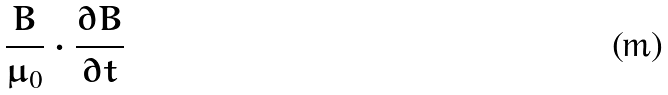<formula> <loc_0><loc_0><loc_500><loc_500>\frac { B } { \mu _ { 0 } } \cdot \frac { \partial B } { \partial t }</formula> 